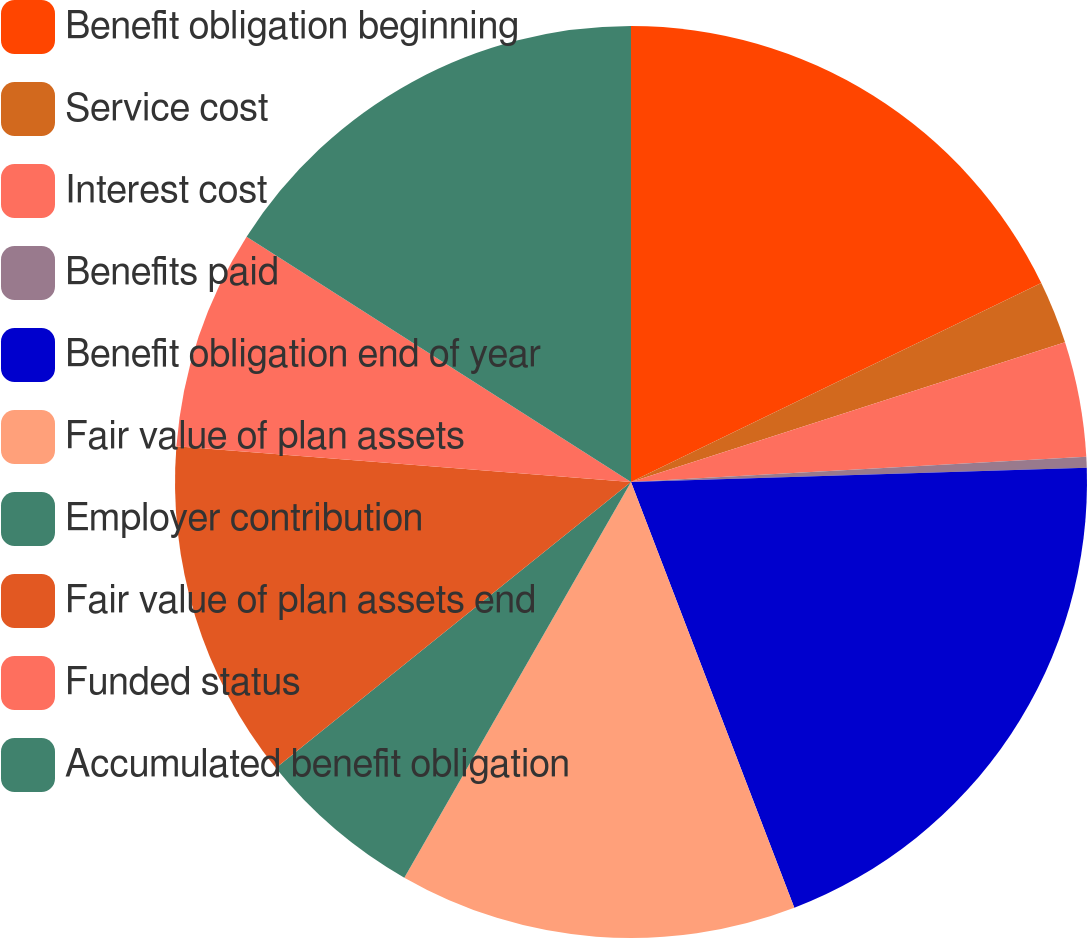Convert chart. <chart><loc_0><loc_0><loc_500><loc_500><pie_chart><fcel>Benefit obligation beginning<fcel>Service cost<fcel>Interest cost<fcel>Benefits paid<fcel>Benefit obligation end of year<fcel>Fair value of plan assets<fcel>Employer contribution<fcel>Fair value of plan assets end<fcel>Funded status<fcel>Accumulated benefit obligation<nl><fcel>17.81%<fcel>2.23%<fcel>4.08%<fcel>0.38%<fcel>19.67%<fcel>14.11%<fcel>5.93%<fcel>12.04%<fcel>7.79%<fcel>15.96%<nl></chart> 